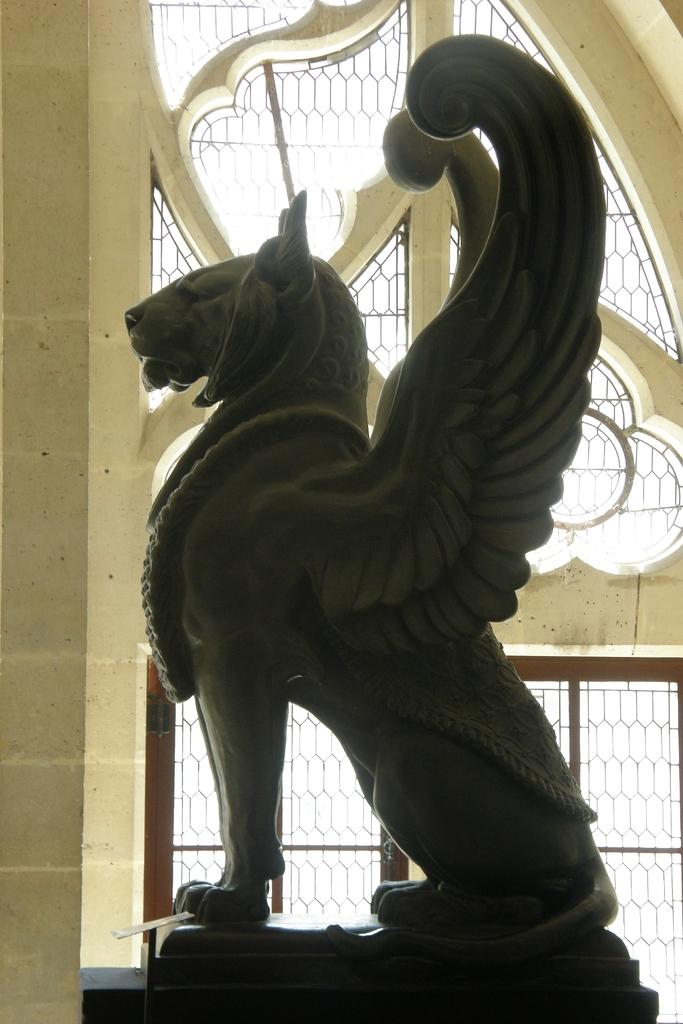What is the main subject of the picture? There is a sculpture of an animal in the picture. What can be seen in the background of the picture? There is a wall and a window in the background of the picture. What type of jeans is the animal wearing in the picture? There is no animal wearing jeans in the picture; it is a sculpture of an animal. What season is depicted in the image based on the presence of winter clothing? There is no indication of a specific season or winter clothing in the image. 